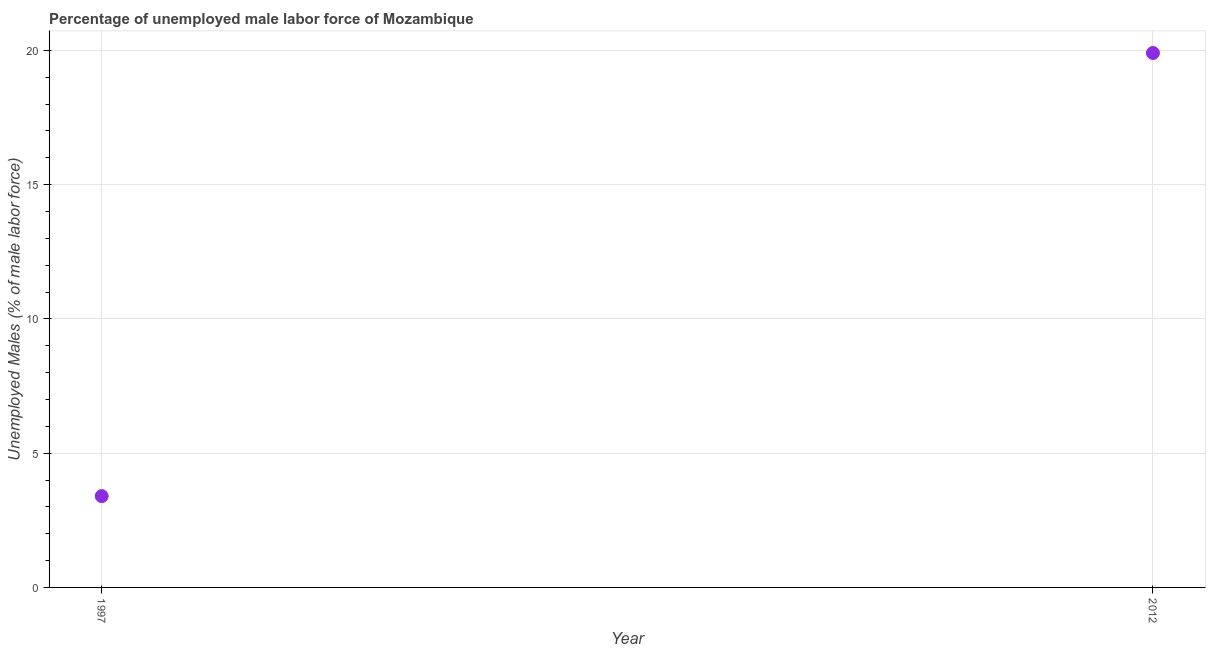What is the total unemployed male labour force in 2012?
Provide a succinct answer. 19.9. Across all years, what is the maximum total unemployed male labour force?
Your answer should be very brief. 19.9. Across all years, what is the minimum total unemployed male labour force?
Give a very brief answer. 3.4. In which year was the total unemployed male labour force minimum?
Give a very brief answer. 1997. What is the sum of the total unemployed male labour force?
Keep it short and to the point. 23.3. What is the difference between the total unemployed male labour force in 1997 and 2012?
Give a very brief answer. -16.5. What is the average total unemployed male labour force per year?
Keep it short and to the point. 11.65. What is the median total unemployed male labour force?
Provide a succinct answer. 11.65. Do a majority of the years between 1997 and 2012 (inclusive) have total unemployed male labour force greater than 2 %?
Your response must be concise. Yes. What is the ratio of the total unemployed male labour force in 1997 to that in 2012?
Keep it short and to the point. 0.17. Does the total unemployed male labour force monotonically increase over the years?
Your answer should be very brief. Yes. How many dotlines are there?
Provide a short and direct response. 1. How many years are there in the graph?
Make the answer very short. 2. What is the difference between two consecutive major ticks on the Y-axis?
Offer a terse response. 5. What is the title of the graph?
Your answer should be compact. Percentage of unemployed male labor force of Mozambique. What is the label or title of the Y-axis?
Your answer should be very brief. Unemployed Males (% of male labor force). What is the Unemployed Males (% of male labor force) in 1997?
Provide a short and direct response. 3.4. What is the Unemployed Males (% of male labor force) in 2012?
Give a very brief answer. 19.9. What is the difference between the Unemployed Males (% of male labor force) in 1997 and 2012?
Provide a succinct answer. -16.5. What is the ratio of the Unemployed Males (% of male labor force) in 1997 to that in 2012?
Offer a very short reply. 0.17. 